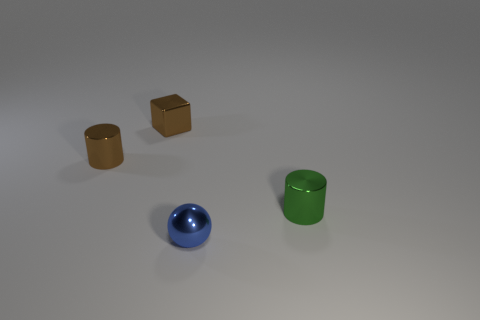What textures can be observed on the surfaces in this image? The surfaces of the objects in the image exhibit a variety of textures. The cubic blocks have a matte finish that indicates a potentially wooden or rough-textured surface. In contrast, the cylindrical objects both have highly reflective, smooth surfaces that resemble polished metal. The floor on which these objects rest appears smooth and offers a muted reflection, contributing to the minimalist aesthetic of the scene. 